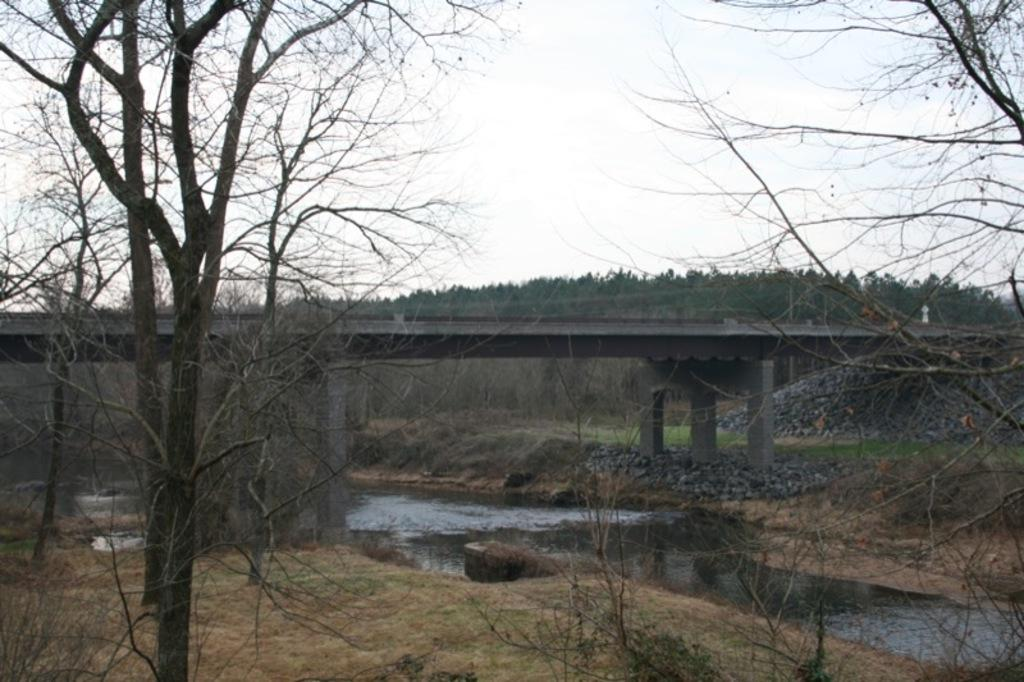What structure can be seen in the image? There is a bridge in the image. What type of vegetation is present in the image? There are trees and plants in the image. What natural element is visible in the image? There is water visible in the image. What part of the natural environment is visible in the image? The sky is visible in the image. What type of sock is hanging from the bridge in the image? There is no sock present in the image; it only features a bridge, trees, plants, water, and the sky. What type of cord is attached to the trees in the image? There is no cord attached to the trees in the image; it only features a bridge, trees, plants, water, and the sky. 